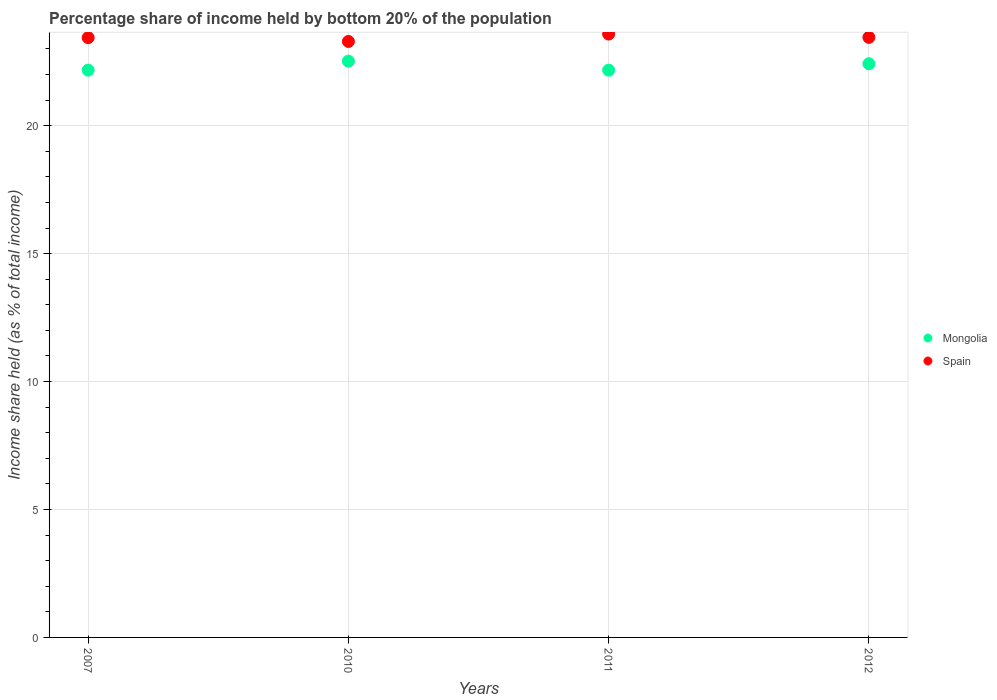Is the number of dotlines equal to the number of legend labels?
Provide a short and direct response. Yes. What is the share of income held by bottom 20% of the population in Mongolia in 2010?
Your response must be concise. 22.52. Across all years, what is the maximum share of income held by bottom 20% of the population in Spain?
Provide a succinct answer. 23.58. Across all years, what is the minimum share of income held by bottom 20% of the population in Mongolia?
Provide a short and direct response. 22.17. What is the total share of income held by bottom 20% of the population in Mongolia in the graph?
Provide a succinct answer. 89.28. What is the difference between the share of income held by bottom 20% of the population in Spain in 2007 and that in 2010?
Offer a very short reply. 0.15. What is the difference between the share of income held by bottom 20% of the population in Mongolia in 2010 and the share of income held by bottom 20% of the population in Spain in 2007?
Ensure brevity in your answer.  -0.92. What is the average share of income held by bottom 20% of the population in Spain per year?
Your response must be concise. 23.44. In the year 2007, what is the difference between the share of income held by bottom 20% of the population in Spain and share of income held by bottom 20% of the population in Mongolia?
Give a very brief answer. 1.27. What is the ratio of the share of income held by bottom 20% of the population in Spain in 2007 to that in 2011?
Your response must be concise. 0.99. Is the difference between the share of income held by bottom 20% of the population in Spain in 2010 and 2012 greater than the difference between the share of income held by bottom 20% of the population in Mongolia in 2010 and 2012?
Your answer should be compact. No. What is the difference between the highest and the second highest share of income held by bottom 20% of the population in Spain?
Provide a short and direct response. 0.13. What is the difference between the highest and the lowest share of income held by bottom 20% of the population in Spain?
Ensure brevity in your answer.  0.29. Is the share of income held by bottom 20% of the population in Spain strictly greater than the share of income held by bottom 20% of the population in Mongolia over the years?
Your answer should be compact. Yes. How many dotlines are there?
Offer a very short reply. 2. Does the graph contain any zero values?
Provide a short and direct response. No. How are the legend labels stacked?
Make the answer very short. Vertical. What is the title of the graph?
Your answer should be compact. Percentage share of income held by bottom 20% of the population. Does "Guam" appear as one of the legend labels in the graph?
Provide a succinct answer. No. What is the label or title of the X-axis?
Make the answer very short. Years. What is the label or title of the Y-axis?
Keep it short and to the point. Income share held (as % of total income). What is the Income share held (as % of total income) in Mongolia in 2007?
Give a very brief answer. 22.17. What is the Income share held (as % of total income) in Spain in 2007?
Ensure brevity in your answer.  23.44. What is the Income share held (as % of total income) in Mongolia in 2010?
Make the answer very short. 22.52. What is the Income share held (as % of total income) of Spain in 2010?
Your answer should be very brief. 23.29. What is the Income share held (as % of total income) of Mongolia in 2011?
Make the answer very short. 22.17. What is the Income share held (as % of total income) in Spain in 2011?
Offer a terse response. 23.58. What is the Income share held (as % of total income) of Mongolia in 2012?
Ensure brevity in your answer.  22.42. What is the Income share held (as % of total income) in Spain in 2012?
Provide a succinct answer. 23.45. Across all years, what is the maximum Income share held (as % of total income) in Mongolia?
Make the answer very short. 22.52. Across all years, what is the maximum Income share held (as % of total income) of Spain?
Give a very brief answer. 23.58. Across all years, what is the minimum Income share held (as % of total income) of Mongolia?
Provide a succinct answer. 22.17. Across all years, what is the minimum Income share held (as % of total income) in Spain?
Your answer should be compact. 23.29. What is the total Income share held (as % of total income) in Mongolia in the graph?
Your answer should be very brief. 89.28. What is the total Income share held (as % of total income) of Spain in the graph?
Offer a terse response. 93.76. What is the difference between the Income share held (as % of total income) in Mongolia in 2007 and that in 2010?
Give a very brief answer. -0.35. What is the difference between the Income share held (as % of total income) in Mongolia in 2007 and that in 2011?
Give a very brief answer. 0. What is the difference between the Income share held (as % of total income) of Spain in 2007 and that in 2011?
Give a very brief answer. -0.14. What is the difference between the Income share held (as % of total income) in Mongolia in 2007 and that in 2012?
Your response must be concise. -0.25. What is the difference between the Income share held (as % of total income) in Spain in 2007 and that in 2012?
Your answer should be very brief. -0.01. What is the difference between the Income share held (as % of total income) in Spain in 2010 and that in 2011?
Give a very brief answer. -0.29. What is the difference between the Income share held (as % of total income) in Spain in 2010 and that in 2012?
Your response must be concise. -0.16. What is the difference between the Income share held (as % of total income) of Mongolia in 2011 and that in 2012?
Offer a very short reply. -0.25. What is the difference between the Income share held (as % of total income) of Spain in 2011 and that in 2012?
Keep it short and to the point. 0.13. What is the difference between the Income share held (as % of total income) in Mongolia in 2007 and the Income share held (as % of total income) in Spain in 2010?
Provide a short and direct response. -1.12. What is the difference between the Income share held (as % of total income) in Mongolia in 2007 and the Income share held (as % of total income) in Spain in 2011?
Give a very brief answer. -1.41. What is the difference between the Income share held (as % of total income) in Mongolia in 2007 and the Income share held (as % of total income) in Spain in 2012?
Make the answer very short. -1.28. What is the difference between the Income share held (as % of total income) in Mongolia in 2010 and the Income share held (as % of total income) in Spain in 2011?
Offer a very short reply. -1.06. What is the difference between the Income share held (as % of total income) in Mongolia in 2010 and the Income share held (as % of total income) in Spain in 2012?
Make the answer very short. -0.93. What is the difference between the Income share held (as % of total income) of Mongolia in 2011 and the Income share held (as % of total income) of Spain in 2012?
Ensure brevity in your answer.  -1.28. What is the average Income share held (as % of total income) in Mongolia per year?
Offer a very short reply. 22.32. What is the average Income share held (as % of total income) of Spain per year?
Your response must be concise. 23.44. In the year 2007, what is the difference between the Income share held (as % of total income) of Mongolia and Income share held (as % of total income) of Spain?
Offer a very short reply. -1.27. In the year 2010, what is the difference between the Income share held (as % of total income) in Mongolia and Income share held (as % of total income) in Spain?
Keep it short and to the point. -0.77. In the year 2011, what is the difference between the Income share held (as % of total income) of Mongolia and Income share held (as % of total income) of Spain?
Your answer should be very brief. -1.41. In the year 2012, what is the difference between the Income share held (as % of total income) of Mongolia and Income share held (as % of total income) of Spain?
Your answer should be compact. -1.03. What is the ratio of the Income share held (as % of total income) of Mongolia in 2007 to that in 2010?
Keep it short and to the point. 0.98. What is the ratio of the Income share held (as % of total income) in Spain in 2007 to that in 2010?
Offer a terse response. 1.01. What is the ratio of the Income share held (as % of total income) of Mongolia in 2007 to that in 2011?
Offer a terse response. 1. What is the ratio of the Income share held (as % of total income) of Spain in 2007 to that in 2011?
Keep it short and to the point. 0.99. What is the ratio of the Income share held (as % of total income) of Mongolia in 2010 to that in 2011?
Keep it short and to the point. 1.02. What is the ratio of the Income share held (as % of total income) in Spain in 2010 to that in 2011?
Keep it short and to the point. 0.99. What is the ratio of the Income share held (as % of total income) of Mongolia in 2010 to that in 2012?
Keep it short and to the point. 1. What is the ratio of the Income share held (as % of total income) in Mongolia in 2011 to that in 2012?
Offer a terse response. 0.99. What is the difference between the highest and the second highest Income share held (as % of total income) in Spain?
Give a very brief answer. 0.13. What is the difference between the highest and the lowest Income share held (as % of total income) in Spain?
Make the answer very short. 0.29. 